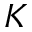Convert formula to latex. <formula><loc_0><loc_0><loc_500><loc_500>K</formula> 